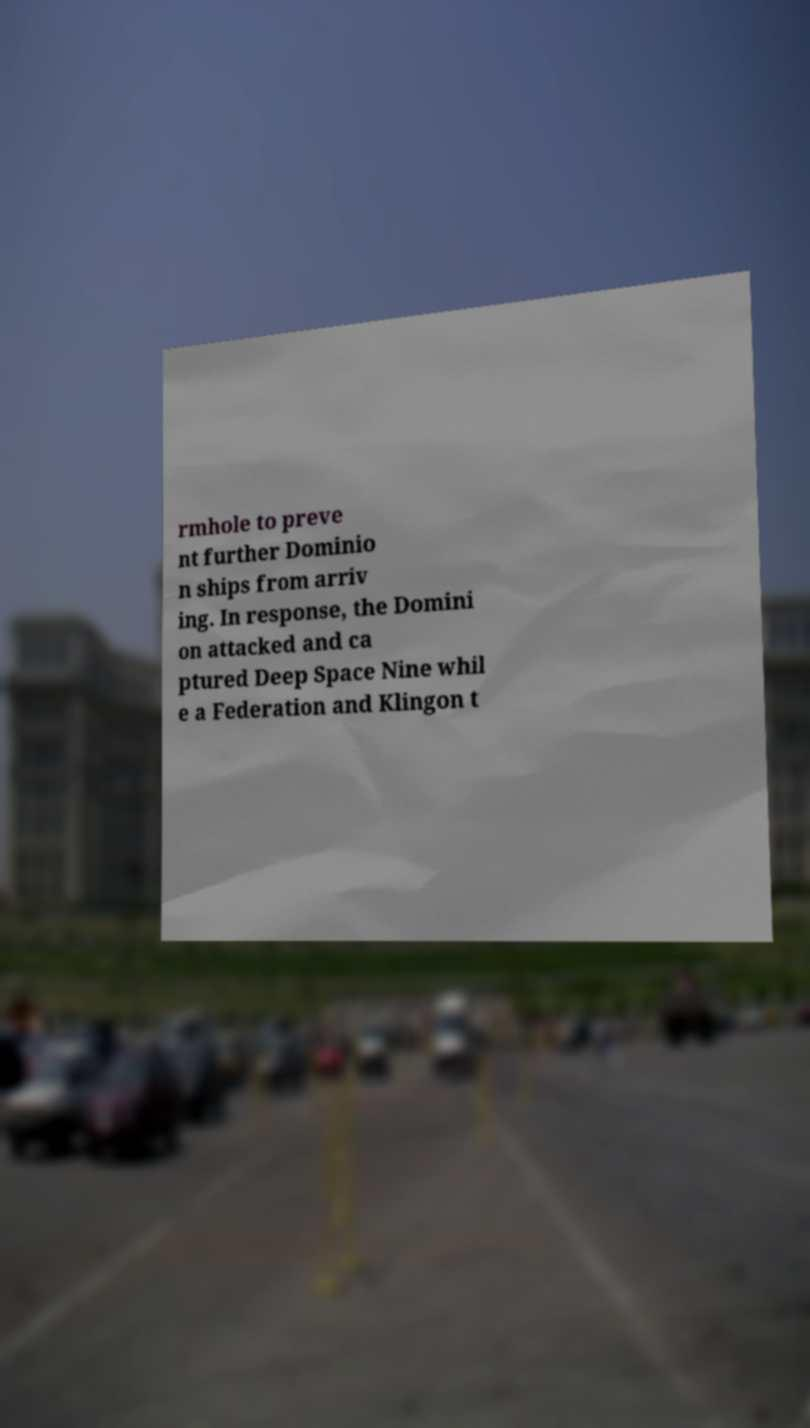Could you extract and type out the text from this image? rmhole to preve nt further Dominio n ships from arriv ing. In response, the Domini on attacked and ca ptured Deep Space Nine whil e a Federation and Klingon t 